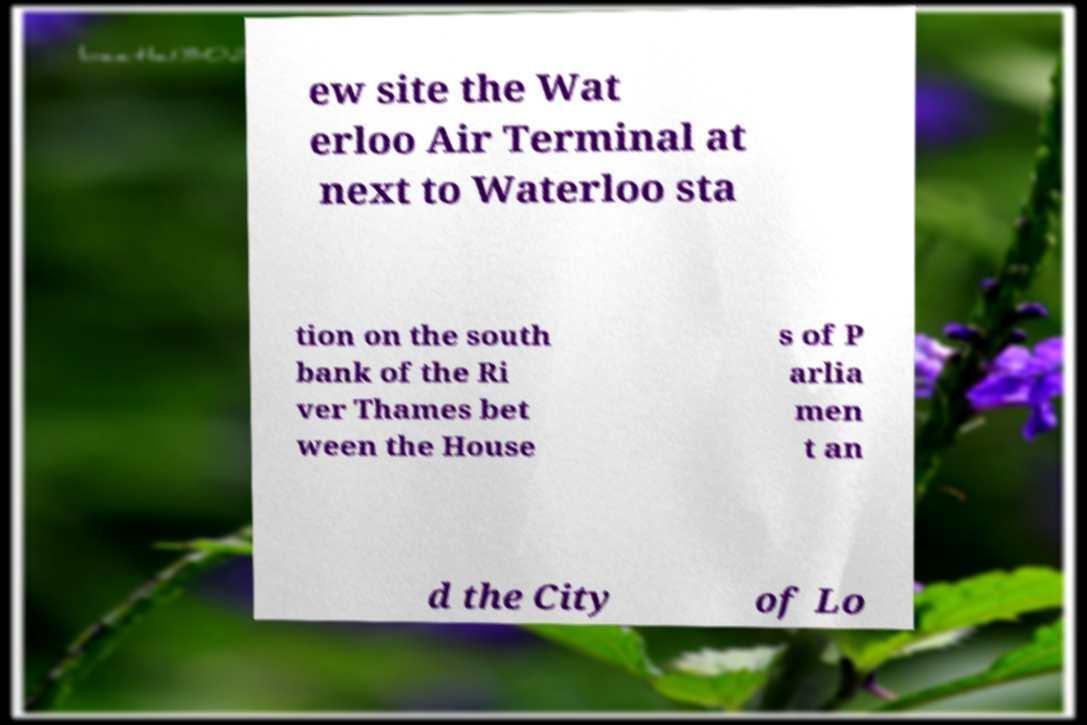For documentation purposes, I need the text within this image transcribed. Could you provide that? ew site the Wat erloo Air Terminal at next to Waterloo sta tion on the south bank of the Ri ver Thames bet ween the House s of P arlia men t an d the City of Lo 